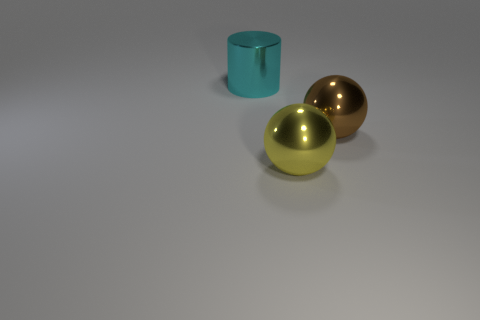What is the color of the metal object that is behind the big ball that is behind the large yellow sphere?
Your response must be concise. Cyan. Are there an equal number of brown things that are behind the brown shiny ball and tiny cubes?
Your answer should be very brief. Yes. What shape is the large metallic object that is both behind the large yellow shiny object and right of the cylinder?
Offer a terse response. Sphere. What is the size of the brown shiny thing that is the same shape as the yellow metallic object?
Provide a succinct answer. Large. Are there fewer brown metallic objects that are behind the brown thing than large shiny spheres?
Your answer should be very brief. Yes. There is a thing on the right side of the big yellow metallic thing; what size is it?
Offer a very short reply. Large. There is another shiny object that is the same shape as the brown thing; what color is it?
Offer a very short reply. Yellow. Is there any other thing that has the same shape as the brown object?
Your response must be concise. Yes. There is a big object right of the metal object in front of the brown sphere; is there a large object in front of it?
Offer a very short reply. Yes. What number of large yellow things are made of the same material as the large cyan cylinder?
Your answer should be very brief. 1. 